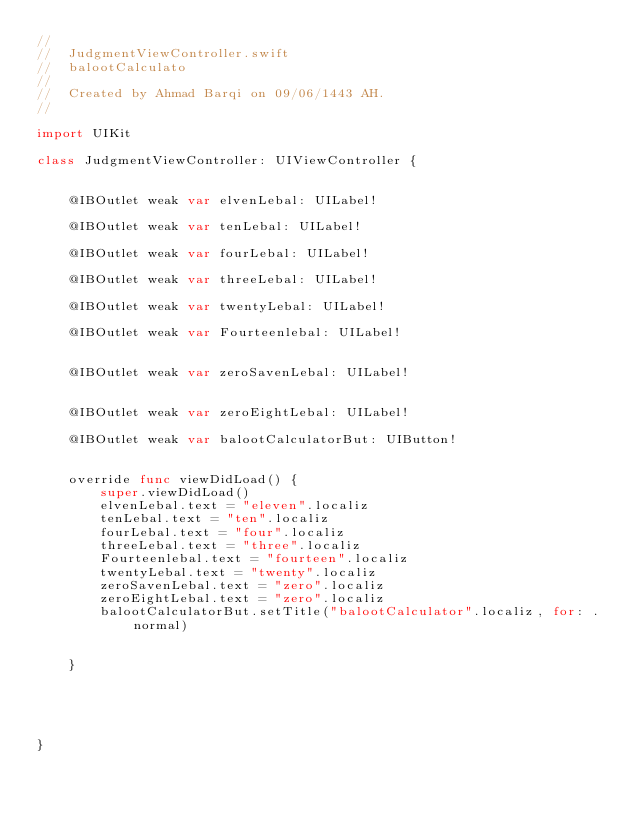<code> <loc_0><loc_0><loc_500><loc_500><_Swift_>//
//  JudgmentViewController.swift
//  balootCalculato
//
//  Created by Ahmad Barqi on 09/06/1443 AH.
//

import UIKit

class JudgmentViewController: UIViewController {

    
    @IBOutlet weak var elvenLebal: UILabel!
    
    @IBOutlet weak var tenLebal: UILabel!
    
    @IBOutlet weak var fourLebal: UILabel!
    
    @IBOutlet weak var threeLebal: UILabel!
    
    @IBOutlet weak var twentyLebal: UILabel!
    
    @IBOutlet weak var Fourteenlebal: UILabel!
    
    
    @IBOutlet weak var zeroSavenLebal: UILabel!
    
    
    @IBOutlet weak var zeroEightLebal: UILabel!
    
    @IBOutlet weak var balootCalculatorBut: UIButton!
    
    
    override func viewDidLoad() {
        super.viewDidLoad()
        elvenLebal.text = "eleven".localiz
        tenLebal.text = "ten".localiz
        fourLebal.text = "four".localiz
        threeLebal.text = "three".localiz
        Fourteenlebal.text = "fourteen".localiz
        twentyLebal.text = "twenty".localiz
        zeroSavenLebal.text = "zero".localiz
        zeroEightLebal.text = "zero".localiz
        balootCalculatorBut.setTitle("balootCalculator".localiz, for: .normal)
        
        
    }
    

    
    
    
}
</code> 